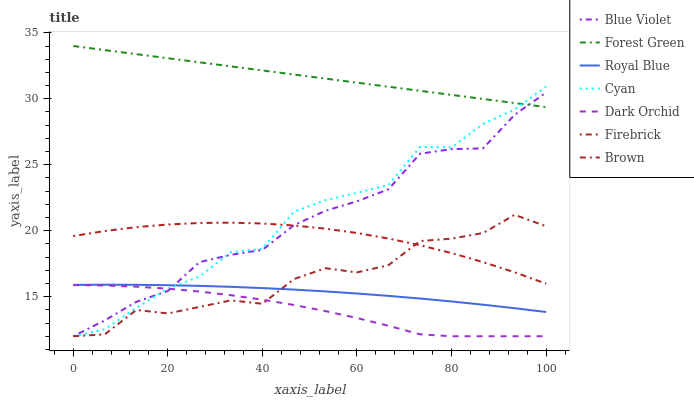Does Dark Orchid have the minimum area under the curve?
Answer yes or no. Yes. Does Forest Green have the maximum area under the curve?
Answer yes or no. Yes. Does Firebrick have the minimum area under the curve?
Answer yes or no. No. Does Firebrick have the maximum area under the curve?
Answer yes or no. No. Is Forest Green the smoothest?
Answer yes or no. Yes. Is Cyan the roughest?
Answer yes or no. Yes. Is Firebrick the smoothest?
Answer yes or no. No. Is Firebrick the roughest?
Answer yes or no. No. Does Brown have the lowest value?
Answer yes or no. Yes. Does Firebrick have the lowest value?
Answer yes or no. No. Does Forest Green have the highest value?
Answer yes or no. Yes. Does Firebrick have the highest value?
Answer yes or no. No. Is Dark Orchid less than Royal Blue?
Answer yes or no. Yes. Is Royal Blue greater than Dark Orchid?
Answer yes or no. Yes. Does Blue Violet intersect Forest Green?
Answer yes or no. Yes. Is Blue Violet less than Forest Green?
Answer yes or no. No. Is Blue Violet greater than Forest Green?
Answer yes or no. No. Does Dark Orchid intersect Royal Blue?
Answer yes or no. No. 